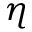Convert formula to latex. <formula><loc_0><loc_0><loc_500><loc_500>\eta</formula> 